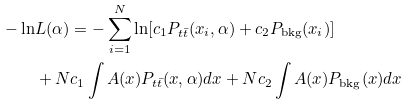<formula> <loc_0><loc_0><loc_500><loc_500>- \ln & L ( \alpha ) = - \sum _ { i = 1 } ^ { N } \ln [ c _ { 1 } P _ { t \bar { t } } ( x _ { i } , \alpha ) + c _ { 2 } P _ { \text {bkg} } ( x _ { i } ) ] \\ & + N c _ { 1 } \int A ( x ) P _ { t \bar { t } } ( x , \alpha ) { d } x + N c _ { 2 } \int A ( x ) P _ { \text {bkg} } ( x ) { d } x</formula> 